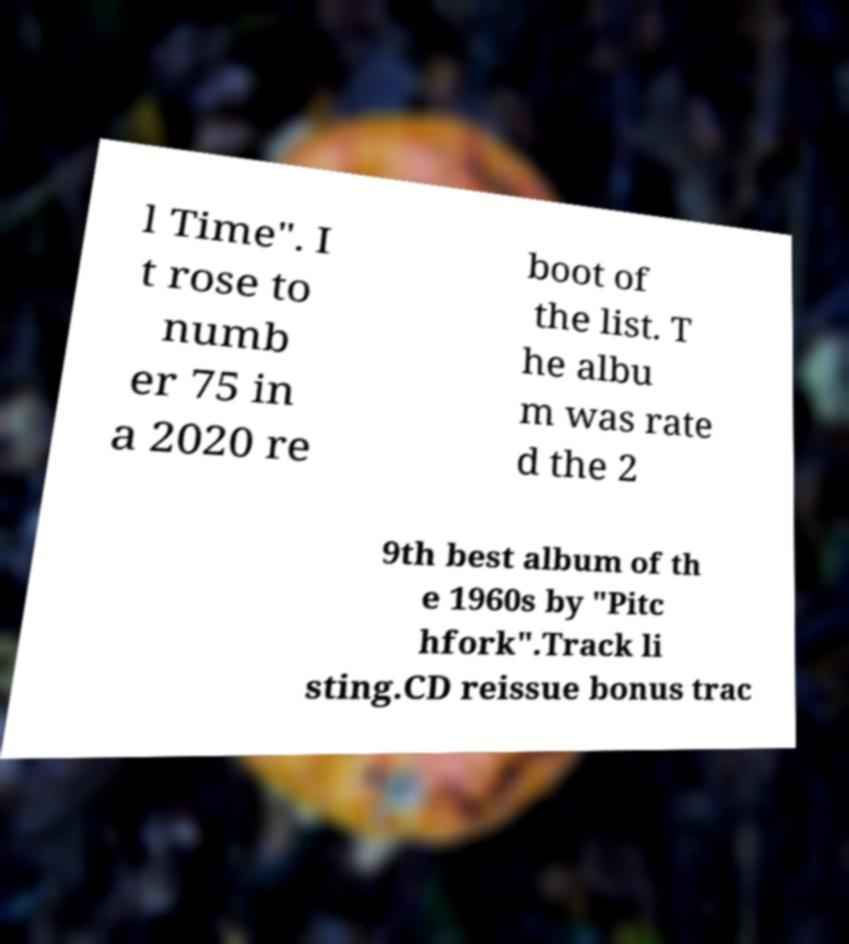I need the written content from this picture converted into text. Can you do that? l Time". I t rose to numb er 75 in a 2020 re boot of the list. T he albu m was rate d the 2 9th best album of th e 1960s by "Pitc hfork".Track li sting.CD reissue bonus trac 